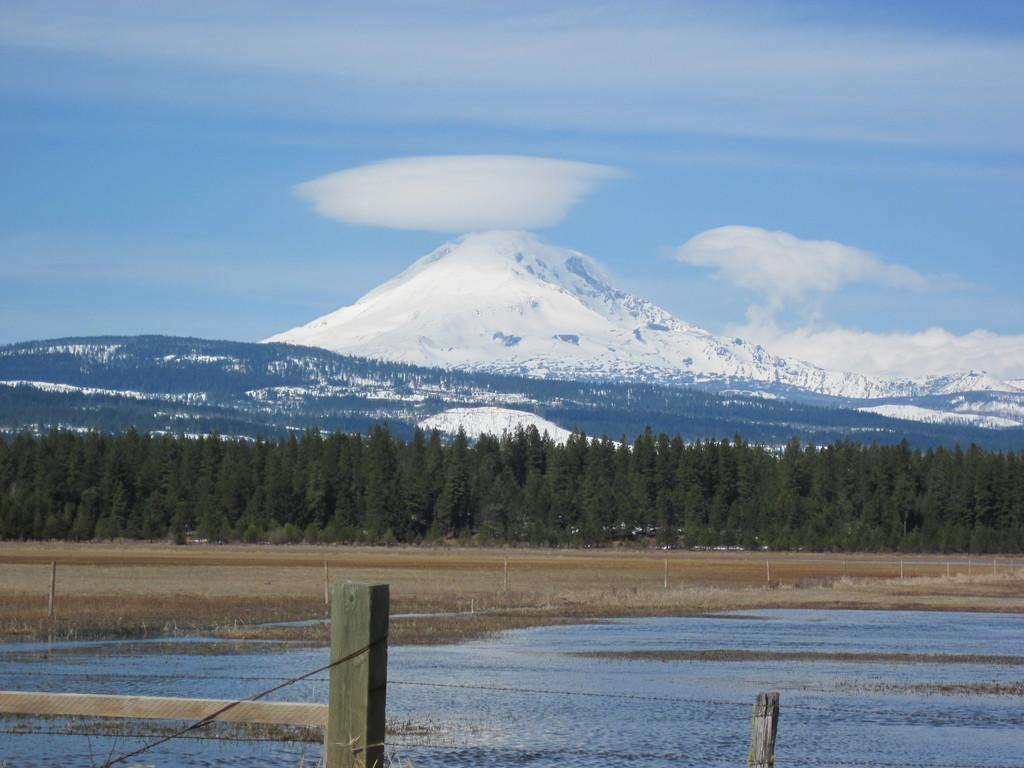What is the primary element visible in the image? Water is visible in the image. What type of fruit is hanging from the toe of the person in the image? There is no person or fruit present in the image, and toes are not mentioned in the provided facts. 